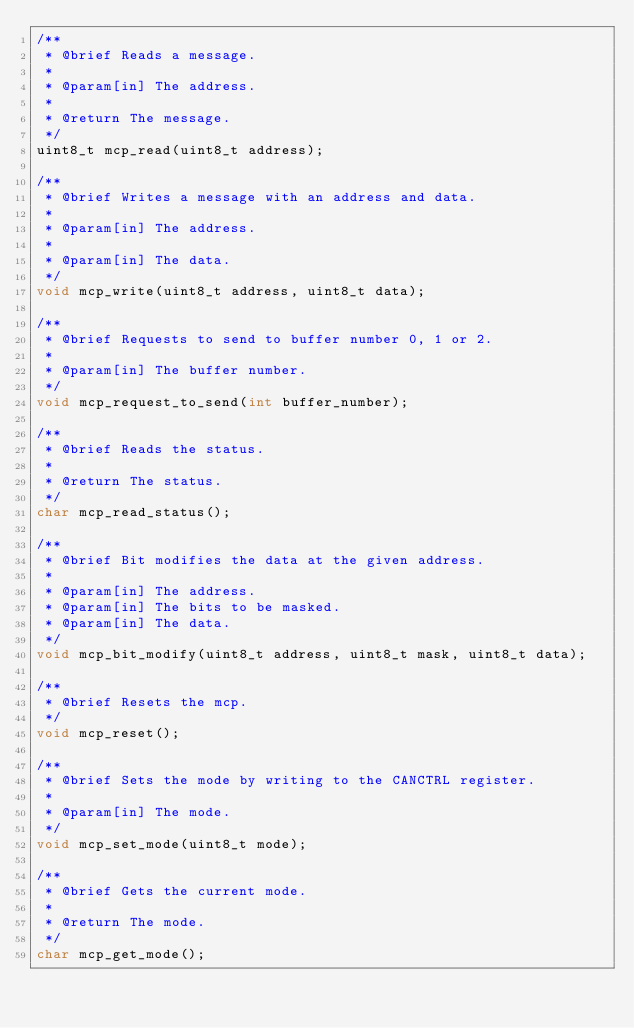Convert code to text. <code><loc_0><loc_0><loc_500><loc_500><_C_>/**
 * @brief Reads a message.
 *
 * @param[in] The address.
 *
 * @return The message.
 */
uint8_t mcp_read(uint8_t address);

/**
 * @brief Writes a message with an address and data.
 *
 * @param[in] The address.
 *
 * @param[in] The data.
 */
void mcp_write(uint8_t address, uint8_t data);

/**
 * @brief Requests to send to buffer number 0, 1 or 2.
 *
 * @param[in] The buffer number.
 */
void mcp_request_to_send(int buffer_number);

/**
 * @brief Reads the status.
 *
 * @return The status.
 */
char mcp_read_status();

/**
 * @brief Bit modifies the data at the given address.
 *
 * @param[in] The address.
 * @param[in] The bits to be masked.
 * @param[in] The data.
 */
void mcp_bit_modify(uint8_t address, uint8_t mask, uint8_t data);

/**
 * @brief Resets the mcp.
 */
void mcp_reset();

/**
 * @brief Sets the mode by writing to the CANCTRL register.
 *
 * @param[in] The mode.
 */
void mcp_set_mode(uint8_t mode);

/**
 * @brief Gets the current mode.
 *
 * @return The mode.
 */
char mcp_get_mode();
</code> 